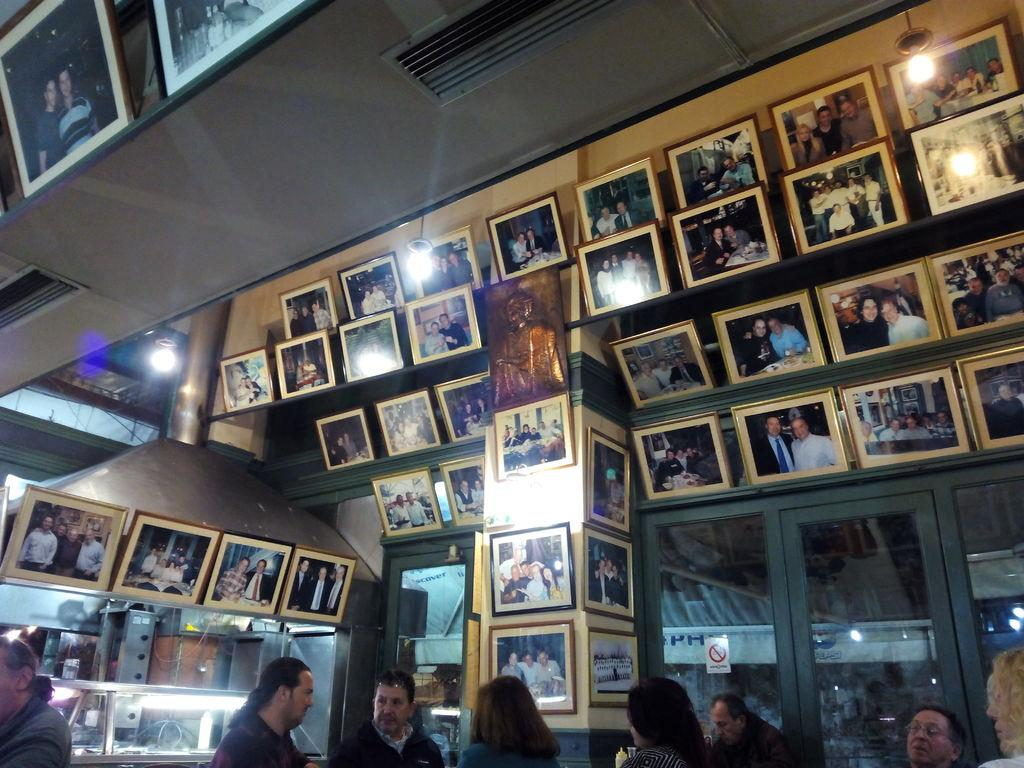Who or what can be seen in the image? There are people in the image. What type of objects are present in the image? There are frames, lights, a poster on a glass, and other objects in the image. Can you describe the poster in the image? The poster is on a glass in the image. What is the annual income of the people in the image? The provided facts do not mention any information about the people's income, so it cannot be determined from the image. 